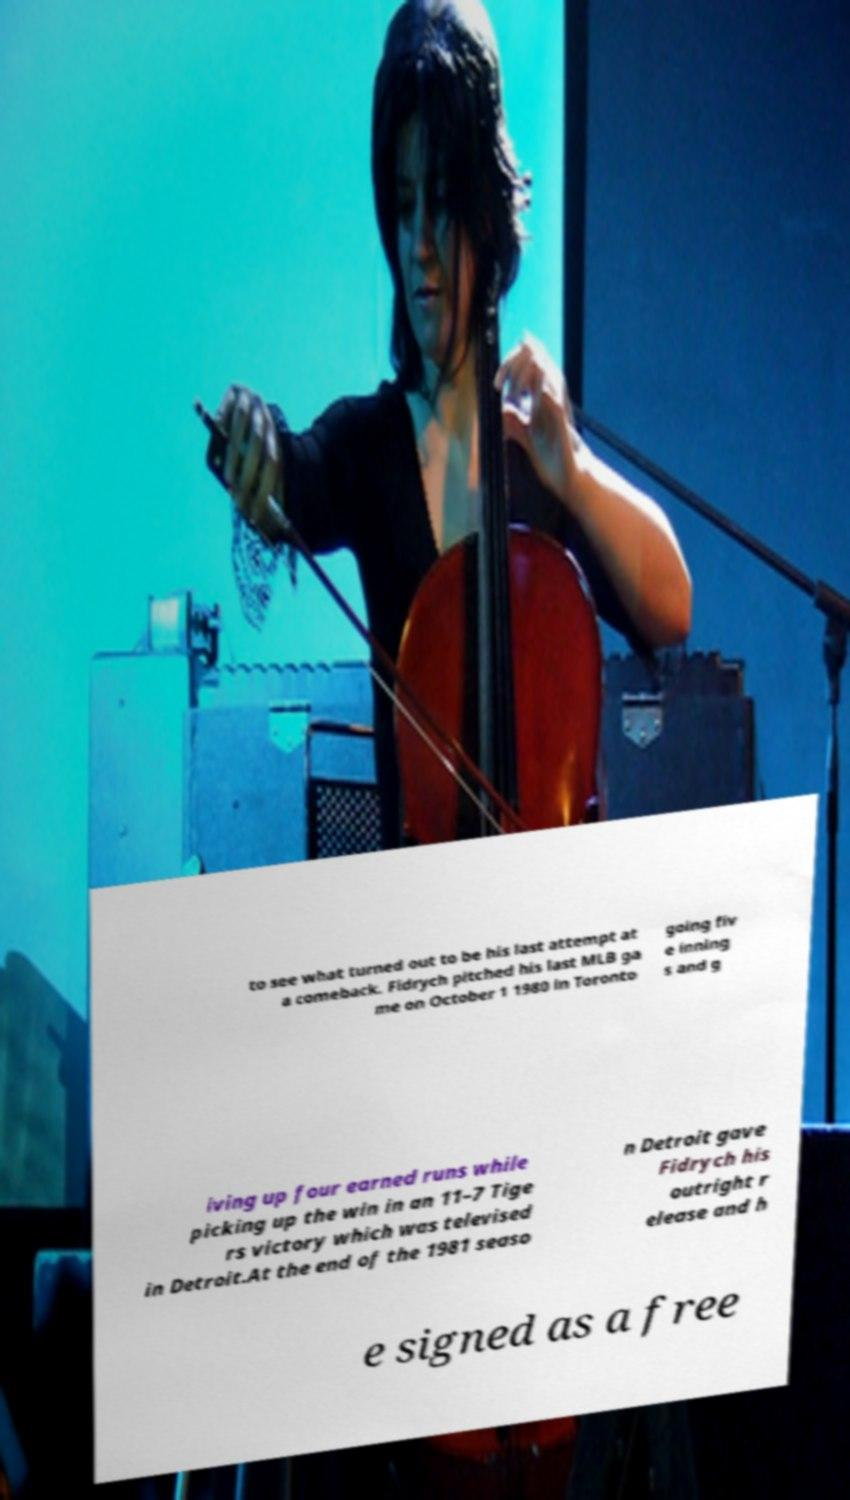There's text embedded in this image that I need extracted. Can you transcribe it verbatim? to see what turned out to be his last attempt at a comeback. Fidrych pitched his last MLB ga me on October 1 1980 in Toronto going fiv e inning s and g iving up four earned runs while picking up the win in an 11–7 Tige rs victory which was televised in Detroit.At the end of the 1981 seaso n Detroit gave Fidrych his outright r elease and h e signed as a free 